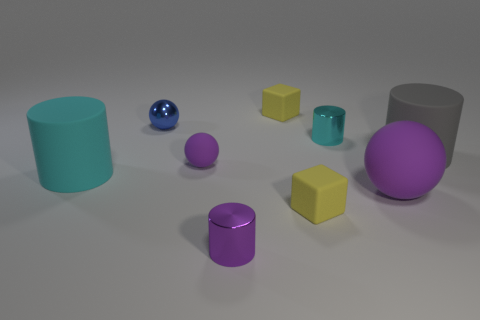The small cube behind the purple matte ball that is on the right side of the small purple shiny thing is made of what material?
Keep it short and to the point. Rubber. How many objects are the same color as the small matte ball?
Your answer should be very brief. 2. What shape is the small blue object that is the same material as the tiny purple cylinder?
Your answer should be very brief. Sphere. What size is the rubber cylinder to the right of the small purple metal object?
Offer a very short reply. Large. Are there an equal number of small cyan objects to the left of the small blue shiny object and small cyan objects that are left of the tiny cyan cylinder?
Give a very brief answer. Yes. What color is the matte cylinder to the right of the shiny cylinder that is on the left side of the small metallic cylinder on the right side of the purple metallic cylinder?
Ensure brevity in your answer.  Gray. What number of matte objects are in front of the small matte sphere and on the right side of the cyan matte cylinder?
Your answer should be very brief. 2. Do the big cylinder to the left of the gray thing and the tiny cylinder behind the small purple metal cylinder have the same color?
Keep it short and to the point. Yes. What size is the cyan rubber thing that is the same shape as the small purple metallic thing?
Keep it short and to the point. Large. There is a blue shiny object; are there any small cubes right of it?
Give a very brief answer. Yes. 